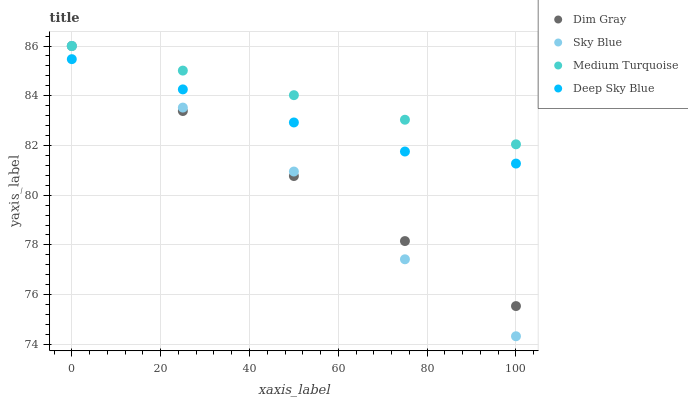Does Sky Blue have the minimum area under the curve?
Answer yes or no. Yes. Does Medium Turquoise have the maximum area under the curve?
Answer yes or no. Yes. Does Dim Gray have the minimum area under the curve?
Answer yes or no. No. Does Dim Gray have the maximum area under the curve?
Answer yes or no. No. Is Medium Turquoise the smoothest?
Answer yes or no. Yes. Is Sky Blue the roughest?
Answer yes or no. Yes. Is Dim Gray the smoothest?
Answer yes or no. No. Is Dim Gray the roughest?
Answer yes or no. No. Does Sky Blue have the lowest value?
Answer yes or no. Yes. Does Dim Gray have the lowest value?
Answer yes or no. No. Does Medium Turquoise have the highest value?
Answer yes or no. Yes. Does Deep Sky Blue have the highest value?
Answer yes or no. No. Is Deep Sky Blue less than Medium Turquoise?
Answer yes or no. Yes. Is Medium Turquoise greater than Deep Sky Blue?
Answer yes or no. Yes. Does Medium Turquoise intersect Dim Gray?
Answer yes or no. Yes. Is Medium Turquoise less than Dim Gray?
Answer yes or no. No. Is Medium Turquoise greater than Dim Gray?
Answer yes or no. No. Does Deep Sky Blue intersect Medium Turquoise?
Answer yes or no. No. 